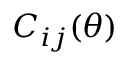<formula> <loc_0><loc_0><loc_500><loc_500>C _ { i j } ( \theta )</formula> 